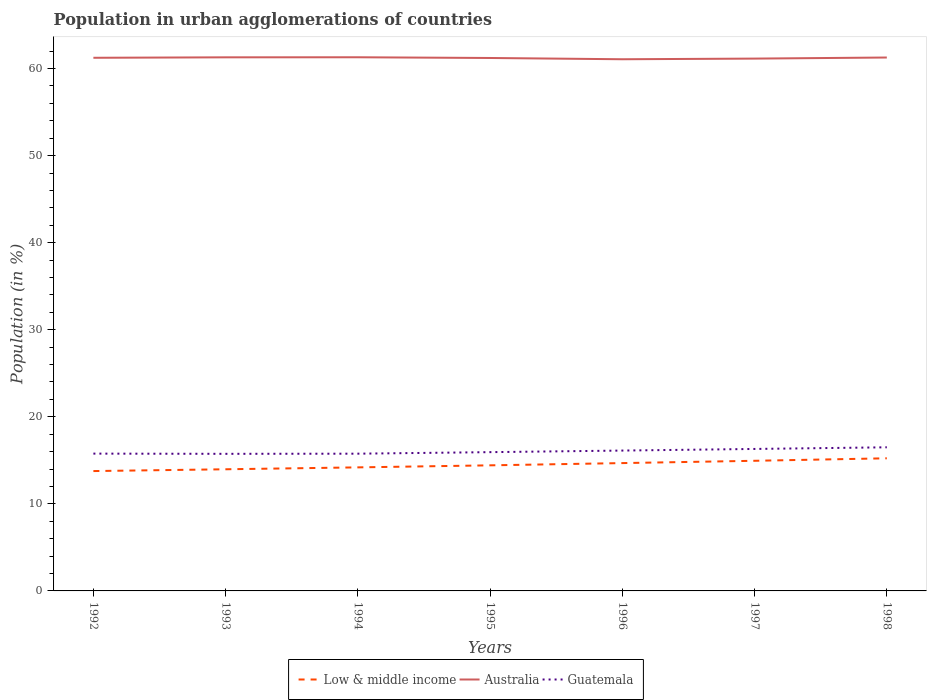How many different coloured lines are there?
Offer a terse response. 3. Does the line corresponding to Australia intersect with the line corresponding to Guatemala?
Make the answer very short. No. Is the number of lines equal to the number of legend labels?
Offer a very short reply. Yes. Across all years, what is the maximum percentage of population in urban agglomerations in Low & middle income?
Your answer should be compact. 13.77. What is the total percentage of population in urban agglomerations in Guatemala in the graph?
Give a very brief answer. -0.18. What is the difference between the highest and the second highest percentage of population in urban agglomerations in Low & middle income?
Give a very brief answer. 1.47. What is the difference between the highest and the lowest percentage of population in urban agglomerations in Guatemala?
Offer a terse response. 3. How many years are there in the graph?
Your answer should be very brief. 7. What is the difference between two consecutive major ticks on the Y-axis?
Make the answer very short. 10. Are the values on the major ticks of Y-axis written in scientific E-notation?
Your response must be concise. No. Does the graph contain any zero values?
Provide a short and direct response. No. Does the graph contain grids?
Give a very brief answer. No. Where does the legend appear in the graph?
Give a very brief answer. Bottom center. What is the title of the graph?
Give a very brief answer. Population in urban agglomerations of countries. Does "Togo" appear as one of the legend labels in the graph?
Make the answer very short. No. What is the label or title of the X-axis?
Your response must be concise. Years. What is the label or title of the Y-axis?
Provide a succinct answer. Population (in %). What is the Population (in %) in Low & middle income in 1992?
Make the answer very short. 13.77. What is the Population (in %) in Australia in 1992?
Keep it short and to the point. 61.24. What is the Population (in %) in Guatemala in 1992?
Provide a succinct answer. 15.77. What is the Population (in %) in Low & middle income in 1993?
Your answer should be compact. 13.97. What is the Population (in %) of Australia in 1993?
Your answer should be compact. 61.29. What is the Population (in %) in Guatemala in 1993?
Your response must be concise. 15.75. What is the Population (in %) of Low & middle income in 1994?
Ensure brevity in your answer.  14.19. What is the Population (in %) in Australia in 1994?
Keep it short and to the point. 61.3. What is the Population (in %) of Guatemala in 1994?
Give a very brief answer. 15.76. What is the Population (in %) in Low & middle income in 1995?
Provide a succinct answer. 14.43. What is the Population (in %) of Australia in 1995?
Your response must be concise. 61.21. What is the Population (in %) in Guatemala in 1995?
Your answer should be very brief. 15.94. What is the Population (in %) of Low & middle income in 1996?
Your answer should be compact. 14.68. What is the Population (in %) in Australia in 1996?
Provide a short and direct response. 61.07. What is the Population (in %) of Guatemala in 1996?
Ensure brevity in your answer.  16.12. What is the Population (in %) of Low & middle income in 1997?
Provide a succinct answer. 14.95. What is the Population (in %) in Australia in 1997?
Offer a terse response. 61.14. What is the Population (in %) of Guatemala in 1997?
Make the answer very short. 16.31. What is the Population (in %) in Low & middle income in 1998?
Your answer should be compact. 15.23. What is the Population (in %) in Australia in 1998?
Make the answer very short. 61.27. What is the Population (in %) of Guatemala in 1998?
Give a very brief answer. 16.5. Across all years, what is the maximum Population (in %) in Low & middle income?
Your answer should be compact. 15.23. Across all years, what is the maximum Population (in %) in Australia?
Offer a terse response. 61.3. Across all years, what is the maximum Population (in %) of Guatemala?
Ensure brevity in your answer.  16.5. Across all years, what is the minimum Population (in %) of Low & middle income?
Give a very brief answer. 13.77. Across all years, what is the minimum Population (in %) of Australia?
Provide a short and direct response. 61.07. Across all years, what is the minimum Population (in %) in Guatemala?
Give a very brief answer. 15.75. What is the total Population (in %) in Low & middle income in the graph?
Give a very brief answer. 101.22. What is the total Population (in %) of Australia in the graph?
Your answer should be very brief. 428.51. What is the total Population (in %) of Guatemala in the graph?
Your answer should be compact. 112.15. What is the difference between the Population (in %) of Low & middle income in 1992 and that in 1993?
Your response must be concise. -0.2. What is the difference between the Population (in %) of Australia in 1992 and that in 1993?
Keep it short and to the point. -0.05. What is the difference between the Population (in %) in Guatemala in 1992 and that in 1993?
Give a very brief answer. 0.02. What is the difference between the Population (in %) in Low & middle income in 1992 and that in 1994?
Make the answer very short. -0.42. What is the difference between the Population (in %) in Australia in 1992 and that in 1994?
Offer a terse response. -0.06. What is the difference between the Population (in %) of Guatemala in 1992 and that in 1994?
Your answer should be compact. 0.01. What is the difference between the Population (in %) of Low & middle income in 1992 and that in 1995?
Make the answer very short. -0.66. What is the difference between the Population (in %) in Australia in 1992 and that in 1995?
Your answer should be compact. 0.02. What is the difference between the Population (in %) of Guatemala in 1992 and that in 1995?
Your answer should be compact. -0.17. What is the difference between the Population (in %) of Low & middle income in 1992 and that in 1996?
Ensure brevity in your answer.  -0.92. What is the difference between the Population (in %) in Australia in 1992 and that in 1996?
Make the answer very short. 0.17. What is the difference between the Population (in %) in Guatemala in 1992 and that in 1996?
Your answer should be compact. -0.35. What is the difference between the Population (in %) in Low & middle income in 1992 and that in 1997?
Keep it short and to the point. -1.18. What is the difference between the Population (in %) of Australia in 1992 and that in 1997?
Provide a succinct answer. 0.09. What is the difference between the Population (in %) in Guatemala in 1992 and that in 1997?
Provide a short and direct response. -0.54. What is the difference between the Population (in %) of Low & middle income in 1992 and that in 1998?
Your answer should be very brief. -1.47. What is the difference between the Population (in %) in Australia in 1992 and that in 1998?
Your response must be concise. -0.03. What is the difference between the Population (in %) in Guatemala in 1992 and that in 1998?
Your answer should be very brief. -0.73. What is the difference between the Population (in %) in Low & middle income in 1993 and that in 1994?
Give a very brief answer. -0.22. What is the difference between the Population (in %) of Australia in 1993 and that in 1994?
Your response must be concise. -0.01. What is the difference between the Population (in %) of Guatemala in 1993 and that in 1994?
Ensure brevity in your answer.  -0.02. What is the difference between the Population (in %) of Low & middle income in 1993 and that in 1995?
Make the answer very short. -0.45. What is the difference between the Population (in %) in Australia in 1993 and that in 1995?
Provide a short and direct response. 0.08. What is the difference between the Population (in %) of Guatemala in 1993 and that in 1995?
Make the answer very short. -0.19. What is the difference between the Population (in %) of Low & middle income in 1993 and that in 1996?
Keep it short and to the point. -0.71. What is the difference between the Population (in %) in Australia in 1993 and that in 1996?
Your response must be concise. 0.22. What is the difference between the Population (in %) of Guatemala in 1993 and that in 1996?
Offer a terse response. -0.38. What is the difference between the Population (in %) in Low & middle income in 1993 and that in 1997?
Offer a terse response. -0.98. What is the difference between the Population (in %) in Australia in 1993 and that in 1997?
Your answer should be very brief. 0.15. What is the difference between the Population (in %) of Guatemala in 1993 and that in 1997?
Your response must be concise. -0.56. What is the difference between the Population (in %) in Low & middle income in 1993 and that in 1998?
Offer a terse response. -1.26. What is the difference between the Population (in %) of Australia in 1993 and that in 1998?
Give a very brief answer. 0.02. What is the difference between the Population (in %) in Guatemala in 1993 and that in 1998?
Make the answer very short. -0.75. What is the difference between the Population (in %) of Low & middle income in 1994 and that in 1995?
Keep it short and to the point. -0.23. What is the difference between the Population (in %) in Australia in 1994 and that in 1995?
Ensure brevity in your answer.  0.08. What is the difference between the Population (in %) in Guatemala in 1994 and that in 1995?
Provide a short and direct response. -0.18. What is the difference between the Population (in %) in Low & middle income in 1994 and that in 1996?
Your response must be concise. -0.49. What is the difference between the Population (in %) of Australia in 1994 and that in 1996?
Make the answer very short. 0.23. What is the difference between the Population (in %) in Guatemala in 1994 and that in 1996?
Your answer should be very brief. -0.36. What is the difference between the Population (in %) of Low & middle income in 1994 and that in 1997?
Make the answer very short. -0.76. What is the difference between the Population (in %) in Australia in 1994 and that in 1997?
Your answer should be compact. 0.15. What is the difference between the Population (in %) in Guatemala in 1994 and that in 1997?
Offer a terse response. -0.54. What is the difference between the Population (in %) in Low & middle income in 1994 and that in 1998?
Provide a short and direct response. -1.04. What is the difference between the Population (in %) in Australia in 1994 and that in 1998?
Give a very brief answer. 0.03. What is the difference between the Population (in %) of Guatemala in 1994 and that in 1998?
Provide a short and direct response. -0.73. What is the difference between the Population (in %) of Low & middle income in 1995 and that in 1996?
Give a very brief answer. -0.26. What is the difference between the Population (in %) in Australia in 1995 and that in 1996?
Keep it short and to the point. 0.14. What is the difference between the Population (in %) of Guatemala in 1995 and that in 1996?
Make the answer very short. -0.18. What is the difference between the Population (in %) in Low & middle income in 1995 and that in 1997?
Your answer should be very brief. -0.52. What is the difference between the Population (in %) of Australia in 1995 and that in 1997?
Your answer should be very brief. 0.07. What is the difference between the Population (in %) of Guatemala in 1995 and that in 1997?
Provide a short and direct response. -0.37. What is the difference between the Population (in %) of Low & middle income in 1995 and that in 1998?
Offer a very short reply. -0.81. What is the difference between the Population (in %) in Australia in 1995 and that in 1998?
Provide a short and direct response. -0.05. What is the difference between the Population (in %) in Guatemala in 1995 and that in 1998?
Your answer should be compact. -0.56. What is the difference between the Population (in %) of Low & middle income in 1996 and that in 1997?
Keep it short and to the point. -0.26. What is the difference between the Population (in %) of Australia in 1996 and that in 1997?
Make the answer very short. -0.08. What is the difference between the Population (in %) of Guatemala in 1996 and that in 1997?
Give a very brief answer. -0.19. What is the difference between the Population (in %) in Low & middle income in 1996 and that in 1998?
Give a very brief answer. -0.55. What is the difference between the Population (in %) in Australia in 1996 and that in 1998?
Keep it short and to the point. -0.2. What is the difference between the Population (in %) in Guatemala in 1996 and that in 1998?
Your response must be concise. -0.37. What is the difference between the Population (in %) in Low & middle income in 1997 and that in 1998?
Your response must be concise. -0.29. What is the difference between the Population (in %) in Australia in 1997 and that in 1998?
Make the answer very short. -0.12. What is the difference between the Population (in %) of Guatemala in 1997 and that in 1998?
Keep it short and to the point. -0.19. What is the difference between the Population (in %) in Low & middle income in 1992 and the Population (in %) in Australia in 1993?
Your answer should be very brief. -47.52. What is the difference between the Population (in %) in Low & middle income in 1992 and the Population (in %) in Guatemala in 1993?
Offer a very short reply. -1.98. What is the difference between the Population (in %) in Australia in 1992 and the Population (in %) in Guatemala in 1993?
Make the answer very short. 45.49. What is the difference between the Population (in %) in Low & middle income in 1992 and the Population (in %) in Australia in 1994?
Make the answer very short. -47.53. What is the difference between the Population (in %) in Low & middle income in 1992 and the Population (in %) in Guatemala in 1994?
Ensure brevity in your answer.  -2. What is the difference between the Population (in %) of Australia in 1992 and the Population (in %) of Guatemala in 1994?
Ensure brevity in your answer.  45.47. What is the difference between the Population (in %) of Low & middle income in 1992 and the Population (in %) of Australia in 1995?
Offer a terse response. -47.45. What is the difference between the Population (in %) in Low & middle income in 1992 and the Population (in %) in Guatemala in 1995?
Your answer should be very brief. -2.17. What is the difference between the Population (in %) in Australia in 1992 and the Population (in %) in Guatemala in 1995?
Make the answer very short. 45.3. What is the difference between the Population (in %) of Low & middle income in 1992 and the Population (in %) of Australia in 1996?
Provide a succinct answer. -47.3. What is the difference between the Population (in %) of Low & middle income in 1992 and the Population (in %) of Guatemala in 1996?
Offer a terse response. -2.35. What is the difference between the Population (in %) of Australia in 1992 and the Population (in %) of Guatemala in 1996?
Offer a terse response. 45.11. What is the difference between the Population (in %) of Low & middle income in 1992 and the Population (in %) of Australia in 1997?
Ensure brevity in your answer.  -47.38. What is the difference between the Population (in %) in Low & middle income in 1992 and the Population (in %) in Guatemala in 1997?
Keep it short and to the point. -2.54. What is the difference between the Population (in %) in Australia in 1992 and the Population (in %) in Guatemala in 1997?
Ensure brevity in your answer.  44.93. What is the difference between the Population (in %) of Low & middle income in 1992 and the Population (in %) of Australia in 1998?
Keep it short and to the point. -47.5. What is the difference between the Population (in %) in Low & middle income in 1992 and the Population (in %) in Guatemala in 1998?
Give a very brief answer. -2.73. What is the difference between the Population (in %) of Australia in 1992 and the Population (in %) of Guatemala in 1998?
Offer a very short reply. 44.74. What is the difference between the Population (in %) in Low & middle income in 1993 and the Population (in %) in Australia in 1994?
Your answer should be very brief. -47.32. What is the difference between the Population (in %) of Low & middle income in 1993 and the Population (in %) of Guatemala in 1994?
Provide a succinct answer. -1.79. What is the difference between the Population (in %) of Australia in 1993 and the Population (in %) of Guatemala in 1994?
Your response must be concise. 45.53. What is the difference between the Population (in %) of Low & middle income in 1993 and the Population (in %) of Australia in 1995?
Give a very brief answer. -47.24. What is the difference between the Population (in %) in Low & middle income in 1993 and the Population (in %) in Guatemala in 1995?
Keep it short and to the point. -1.97. What is the difference between the Population (in %) of Australia in 1993 and the Population (in %) of Guatemala in 1995?
Offer a terse response. 45.35. What is the difference between the Population (in %) of Low & middle income in 1993 and the Population (in %) of Australia in 1996?
Your answer should be very brief. -47.1. What is the difference between the Population (in %) of Low & middle income in 1993 and the Population (in %) of Guatemala in 1996?
Keep it short and to the point. -2.15. What is the difference between the Population (in %) in Australia in 1993 and the Population (in %) in Guatemala in 1996?
Your answer should be compact. 45.17. What is the difference between the Population (in %) in Low & middle income in 1993 and the Population (in %) in Australia in 1997?
Your response must be concise. -47.17. What is the difference between the Population (in %) of Low & middle income in 1993 and the Population (in %) of Guatemala in 1997?
Offer a very short reply. -2.33. What is the difference between the Population (in %) of Australia in 1993 and the Population (in %) of Guatemala in 1997?
Ensure brevity in your answer.  44.98. What is the difference between the Population (in %) in Low & middle income in 1993 and the Population (in %) in Australia in 1998?
Your response must be concise. -47.3. What is the difference between the Population (in %) in Low & middle income in 1993 and the Population (in %) in Guatemala in 1998?
Offer a terse response. -2.52. What is the difference between the Population (in %) of Australia in 1993 and the Population (in %) of Guatemala in 1998?
Your answer should be compact. 44.79. What is the difference between the Population (in %) of Low & middle income in 1994 and the Population (in %) of Australia in 1995?
Make the answer very short. -47.02. What is the difference between the Population (in %) in Low & middle income in 1994 and the Population (in %) in Guatemala in 1995?
Offer a very short reply. -1.75. What is the difference between the Population (in %) of Australia in 1994 and the Population (in %) of Guatemala in 1995?
Make the answer very short. 45.36. What is the difference between the Population (in %) in Low & middle income in 1994 and the Population (in %) in Australia in 1996?
Your answer should be very brief. -46.88. What is the difference between the Population (in %) in Low & middle income in 1994 and the Population (in %) in Guatemala in 1996?
Offer a terse response. -1.93. What is the difference between the Population (in %) of Australia in 1994 and the Population (in %) of Guatemala in 1996?
Make the answer very short. 45.17. What is the difference between the Population (in %) of Low & middle income in 1994 and the Population (in %) of Australia in 1997?
Offer a very short reply. -46.95. What is the difference between the Population (in %) of Low & middle income in 1994 and the Population (in %) of Guatemala in 1997?
Your answer should be compact. -2.12. What is the difference between the Population (in %) in Australia in 1994 and the Population (in %) in Guatemala in 1997?
Make the answer very short. 44.99. What is the difference between the Population (in %) in Low & middle income in 1994 and the Population (in %) in Australia in 1998?
Keep it short and to the point. -47.08. What is the difference between the Population (in %) of Low & middle income in 1994 and the Population (in %) of Guatemala in 1998?
Your response must be concise. -2.31. What is the difference between the Population (in %) in Australia in 1994 and the Population (in %) in Guatemala in 1998?
Provide a succinct answer. 44.8. What is the difference between the Population (in %) in Low & middle income in 1995 and the Population (in %) in Australia in 1996?
Make the answer very short. -46.64. What is the difference between the Population (in %) in Low & middle income in 1995 and the Population (in %) in Guatemala in 1996?
Give a very brief answer. -1.7. What is the difference between the Population (in %) in Australia in 1995 and the Population (in %) in Guatemala in 1996?
Provide a short and direct response. 45.09. What is the difference between the Population (in %) of Low & middle income in 1995 and the Population (in %) of Australia in 1997?
Keep it short and to the point. -46.72. What is the difference between the Population (in %) in Low & middle income in 1995 and the Population (in %) in Guatemala in 1997?
Make the answer very short. -1.88. What is the difference between the Population (in %) in Australia in 1995 and the Population (in %) in Guatemala in 1997?
Provide a succinct answer. 44.91. What is the difference between the Population (in %) of Low & middle income in 1995 and the Population (in %) of Australia in 1998?
Offer a very short reply. -46.84. What is the difference between the Population (in %) of Low & middle income in 1995 and the Population (in %) of Guatemala in 1998?
Offer a terse response. -2.07. What is the difference between the Population (in %) of Australia in 1995 and the Population (in %) of Guatemala in 1998?
Offer a very short reply. 44.72. What is the difference between the Population (in %) of Low & middle income in 1996 and the Population (in %) of Australia in 1997?
Provide a short and direct response. -46.46. What is the difference between the Population (in %) of Low & middle income in 1996 and the Population (in %) of Guatemala in 1997?
Your answer should be compact. -1.62. What is the difference between the Population (in %) of Australia in 1996 and the Population (in %) of Guatemala in 1997?
Your answer should be very brief. 44.76. What is the difference between the Population (in %) in Low & middle income in 1996 and the Population (in %) in Australia in 1998?
Your answer should be very brief. -46.58. What is the difference between the Population (in %) of Low & middle income in 1996 and the Population (in %) of Guatemala in 1998?
Provide a short and direct response. -1.81. What is the difference between the Population (in %) in Australia in 1996 and the Population (in %) in Guatemala in 1998?
Keep it short and to the point. 44.57. What is the difference between the Population (in %) of Low & middle income in 1997 and the Population (in %) of Australia in 1998?
Offer a terse response. -46.32. What is the difference between the Population (in %) of Low & middle income in 1997 and the Population (in %) of Guatemala in 1998?
Provide a short and direct response. -1.55. What is the difference between the Population (in %) in Australia in 1997 and the Population (in %) in Guatemala in 1998?
Provide a succinct answer. 44.65. What is the average Population (in %) of Low & middle income per year?
Offer a very short reply. 14.46. What is the average Population (in %) in Australia per year?
Offer a terse response. 61.22. What is the average Population (in %) in Guatemala per year?
Your answer should be very brief. 16.02. In the year 1992, what is the difference between the Population (in %) in Low & middle income and Population (in %) in Australia?
Your answer should be very brief. -47.47. In the year 1992, what is the difference between the Population (in %) in Low & middle income and Population (in %) in Guatemala?
Provide a succinct answer. -2. In the year 1992, what is the difference between the Population (in %) in Australia and Population (in %) in Guatemala?
Keep it short and to the point. 45.46. In the year 1993, what is the difference between the Population (in %) of Low & middle income and Population (in %) of Australia?
Give a very brief answer. -47.32. In the year 1993, what is the difference between the Population (in %) of Low & middle income and Population (in %) of Guatemala?
Offer a terse response. -1.77. In the year 1993, what is the difference between the Population (in %) in Australia and Population (in %) in Guatemala?
Offer a terse response. 45.54. In the year 1994, what is the difference between the Population (in %) of Low & middle income and Population (in %) of Australia?
Your response must be concise. -47.1. In the year 1994, what is the difference between the Population (in %) in Low & middle income and Population (in %) in Guatemala?
Ensure brevity in your answer.  -1.57. In the year 1994, what is the difference between the Population (in %) in Australia and Population (in %) in Guatemala?
Ensure brevity in your answer.  45.53. In the year 1995, what is the difference between the Population (in %) of Low & middle income and Population (in %) of Australia?
Your response must be concise. -46.79. In the year 1995, what is the difference between the Population (in %) in Low & middle income and Population (in %) in Guatemala?
Provide a short and direct response. -1.51. In the year 1995, what is the difference between the Population (in %) of Australia and Population (in %) of Guatemala?
Ensure brevity in your answer.  45.27. In the year 1996, what is the difference between the Population (in %) of Low & middle income and Population (in %) of Australia?
Offer a very short reply. -46.39. In the year 1996, what is the difference between the Population (in %) in Low & middle income and Population (in %) in Guatemala?
Provide a succinct answer. -1.44. In the year 1996, what is the difference between the Population (in %) in Australia and Population (in %) in Guatemala?
Offer a terse response. 44.95. In the year 1997, what is the difference between the Population (in %) in Low & middle income and Population (in %) in Australia?
Your answer should be very brief. -46.2. In the year 1997, what is the difference between the Population (in %) in Low & middle income and Population (in %) in Guatemala?
Ensure brevity in your answer.  -1.36. In the year 1997, what is the difference between the Population (in %) in Australia and Population (in %) in Guatemala?
Keep it short and to the point. 44.84. In the year 1998, what is the difference between the Population (in %) in Low & middle income and Population (in %) in Australia?
Ensure brevity in your answer.  -46.03. In the year 1998, what is the difference between the Population (in %) in Low & middle income and Population (in %) in Guatemala?
Your response must be concise. -1.26. In the year 1998, what is the difference between the Population (in %) of Australia and Population (in %) of Guatemala?
Offer a terse response. 44.77. What is the ratio of the Population (in %) of Guatemala in 1992 to that in 1993?
Make the answer very short. 1. What is the ratio of the Population (in %) of Low & middle income in 1992 to that in 1994?
Provide a short and direct response. 0.97. What is the ratio of the Population (in %) in Australia in 1992 to that in 1994?
Keep it short and to the point. 1. What is the ratio of the Population (in %) of Low & middle income in 1992 to that in 1995?
Your answer should be very brief. 0.95. What is the ratio of the Population (in %) in Guatemala in 1992 to that in 1995?
Keep it short and to the point. 0.99. What is the ratio of the Population (in %) of Low & middle income in 1992 to that in 1996?
Your answer should be compact. 0.94. What is the ratio of the Population (in %) in Guatemala in 1992 to that in 1996?
Ensure brevity in your answer.  0.98. What is the ratio of the Population (in %) in Low & middle income in 1992 to that in 1997?
Your answer should be compact. 0.92. What is the ratio of the Population (in %) of Australia in 1992 to that in 1997?
Provide a succinct answer. 1. What is the ratio of the Population (in %) in Guatemala in 1992 to that in 1997?
Provide a succinct answer. 0.97. What is the ratio of the Population (in %) in Low & middle income in 1992 to that in 1998?
Provide a short and direct response. 0.9. What is the ratio of the Population (in %) in Australia in 1992 to that in 1998?
Provide a succinct answer. 1. What is the ratio of the Population (in %) in Guatemala in 1992 to that in 1998?
Offer a very short reply. 0.96. What is the ratio of the Population (in %) of Low & middle income in 1993 to that in 1994?
Your answer should be compact. 0.98. What is the ratio of the Population (in %) of Low & middle income in 1993 to that in 1995?
Provide a short and direct response. 0.97. What is the ratio of the Population (in %) of Guatemala in 1993 to that in 1995?
Offer a very short reply. 0.99. What is the ratio of the Population (in %) of Low & middle income in 1993 to that in 1996?
Provide a short and direct response. 0.95. What is the ratio of the Population (in %) of Guatemala in 1993 to that in 1996?
Provide a succinct answer. 0.98. What is the ratio of the Population (in %) of Low & middle income in 1993 to that in 1997?
Ensure brevity in your answer.  0.93. What is the ratio of the Population (in %) in Guatemala in 1993 to that in 1997?
Offer a terse response. 0.97. What is the ratio of the Population (in %) of Low & middle income in 1993 to that in 1998?
Make the answer very short. 0.92. What is the ratio of the Population (in %) of Guatemala in 1993 to that in 1998?
Ensure brevity in your answer.  0.95. What is the ratio of the Population (in %) of Low & middle income in 1994 to that in 1995?
Provide a short and direct response. 0.98. What is the ratio of the Population (in %) in Low & middle income in 1994 to that in 1996?
Your answer should be compact. 0.97. What is the ratio of the Population (in %) of Guatemala in 1994 to that in 1996?
Your response must be concise. 0.98. What is the ratio of the Population (in %) of Low & middle income in 1994 to that in 1997?
Make the answer very short. 0.95. What is the ratio of the Population (in %) in Guatemala in 1994 to that in 1997?
Your response must be concise. 0.97. What is the ratio of the Population (in %) in Low & middle income in 1994 to that in 1998?
Offer a terse response. 0.93. What is the ratio of the Population (in %) of Australia in 1994 to that in 1998?
Your response must be concise. 1. What is the ratio of the Population (in %) in Guatemala in 1994 to that in 1998?
Your answer should be compact. 0.96. What is the ratio of the Population (in %) in Low & middle income in 1995 to that in 1996?
Give a very brief answer. 0.98. What is the ratio of the Population (in %) of Guatemala in 1995 to that in 1996?
Your response must be concise. 0.99. What is the ratio of the Population (in %) of Low & middle income in 1995 to that in 1997?
Provide a short and direct response. 0.97. What is the ratio of the Population (in %) in Australia in 1995 to that in 1997?
Your answer should be very brief. 1. What is the ratio of the Population (in %) in Guatemala in 1995 to that in 1997?
Offer a terse response. 0.98. What is the ratio of the Population (in %) of Low & middle income in 1995 to that in 1998?
Make the answer very short. 0.95. What is the ratio of the Population (in %) of Guatemala in 1995 to that in 1998?
Keep it short and to the point. 0.97. What is the ratio of the Population (in %) in Low & middle income in 1996 to that in 1997?
Make the answer very short. 0.98. What is the ratio of the Population (in %) in Low & middle income in 1996 to that in 1998?
Offer a very short reply. 0.96. What is the ratio of the Population (in %) of Guatemala in 1996 to that in 1998?
Ensure brevity in your answer.  0.98. What is the ratio of the Population (in %) of Low & middle income in 1997 to that in 1998?
Give a very brief answer. 0.98. What is the ratio of the Population (in %) of Australia in 1997 to that in 1998?
Offer a very short reply. 1. What is the ratio of the Population (in %) of Guatemala in 1997 to that in 1998?
Keep it short and to the point. 0.99. What is the difference between the highest and the second highest Population (in %) of Low & middle income?
Offer a terse response. 0.29. What is the difference between the highest and the second highest Population (in %) of Australia?
Ensure brevity in your answer.  0.01. What is the difference between the highest and the second highest Population (in %) in Guatemala?
Offer a terse response. 0.19. What is the difference between the highest and the lowest Population (in %) in Low & middle income?
Ensure brevity in your answer.  1.47. What is the difference between the highest and the lowest Population (in %) of Australia?
Offer a terse response. 0.23. What is the difference between the highest and the lowest Population (in %) of Guatemala?
Your answer should be compact. 0.75. 